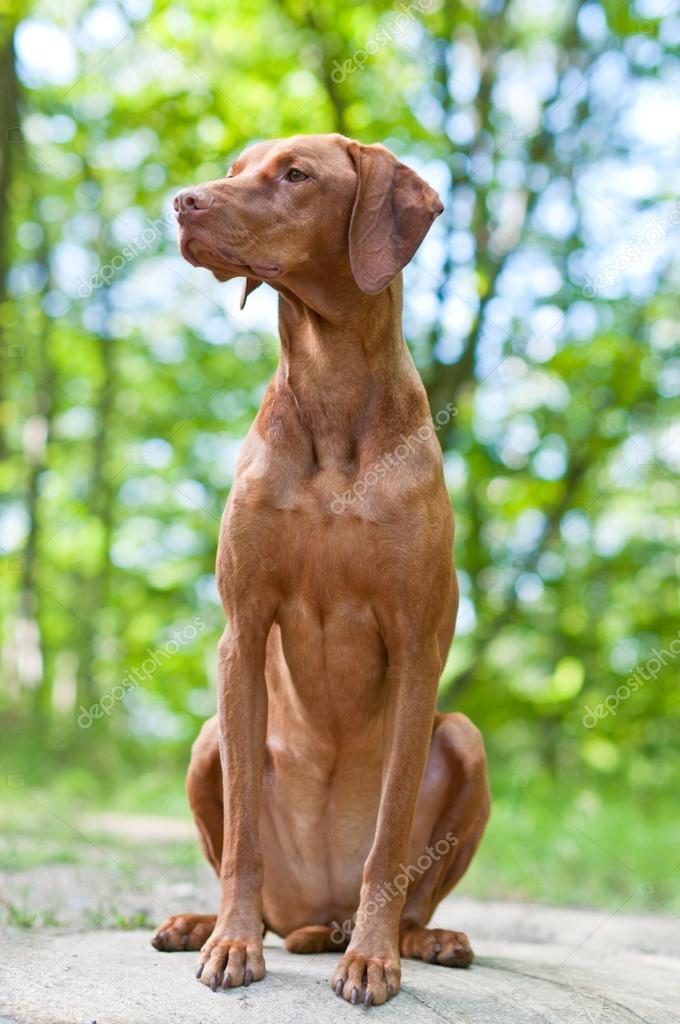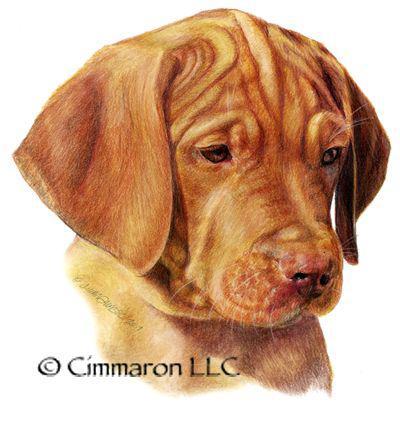The first image is the image on the left, the second image is the image on the right. Given the left and right images, does the statement "In at least one image, there is a redbone coonhound sitting with his head facing left." hold true? Answer yes or no. Yes. The first image is the image on the left, the second image is the image on the right. Assess this claim about the two images: "The right image contains a red-orange dog with an upright head gazing straight ahead, and the left image contains a dog with its muzzle pointing rightward.". Correct or not? Answer yes or no. No. 